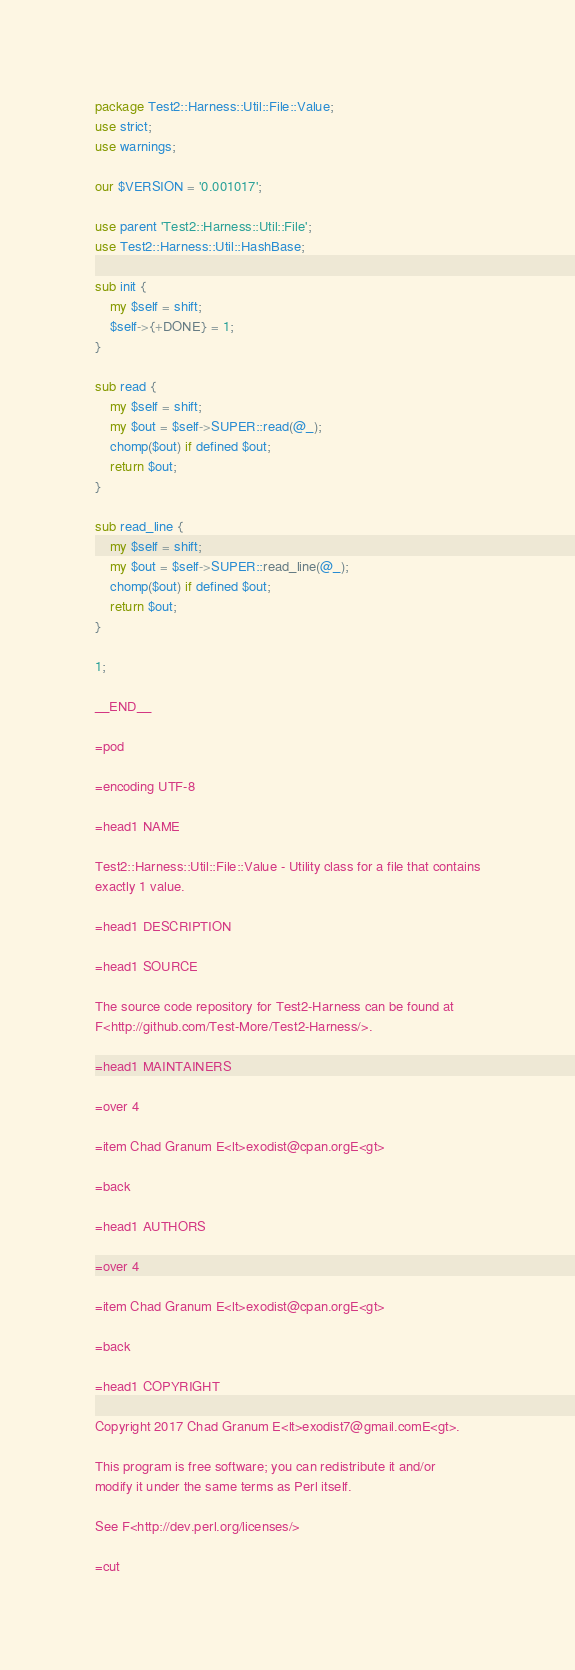<code> <loc_0><loc_0><loc_500><loc_500><_Perl_>package Test2::Harness::Util::File::Value;
use strict;
use warnings;

our $VERSION = '0.001017';

use parent 'Test2::Harness::Util::File';
use Test2::Harness::Util::HashBase;

sub init {
    my $self = shift;
    $self->{+DONE} = 1;
}

sub read {
    my $self = shift;
    my $out = $self->SUPER::read(@_);
    chomp($out) if defined $out;
    return $out;
}

sub read_line {
    my $self = shift;
    my $out = $self->SUPER::read_line(@_);
    chomp($out) if defined $out;
    return $out;
}

1;

__END__

=pod

=encoding UTF-8

=head1 NAME

Test2::Harness::Util::File::Value - Utility class for a file that contains
exactly 1 value.

=head1 DESCRIPTION

=head1 SOURCE

The source code repository for Test2-Harness can be found at
F<http://github.com/Test-More/Test2-Harness/>.

=head1 MAINTAINERS

=over 4

=item Chad Granum E<lt>exodist@cpan.orgE<gt>

=back

=head1 AUTHORS

=over 4

=item Chad Granum E<lt>exodist@cpan.orgE<gt>

=back

=head1 COPYRIGHT

Copyright 2017 Chad Granum E<lt>exodist7@gmail.comE<gt>.

This program is free software; you can redistribute it and/or
modify it under the same terms as Perl itself.

See F<http://dev.perl.org/licenses/>

=cut
</code> 